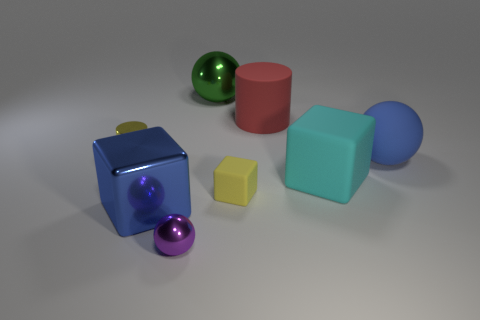Add 1 tiny cubes. How many objects exist? 9 Subtract all green spheres. How many spheres are left? 2 Subtract all blue cubes. How many cubes are left? 2 Subtract 1 blue balls. How many objects are left? 7 Subtract all balls. How many objects are left? 5 Subtract 1 cylinders. How many cylinders are left? 1 Subtract all brown blocks. Subtract all green cylinders. How many blocks are left? 3 Subtract all gray balls. How many cyan blocks are left? 1 Subtract all tiny brown rubber things. Subtract all rubber balls. How many objects are left? 7 Add 3 rubber cylinders. How many rubber cylinders are left? 4 